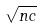Convert formula to latex. <formula><loc_0><loc_0><loc_500><loc_500>\sqrt { n c }</formula> 